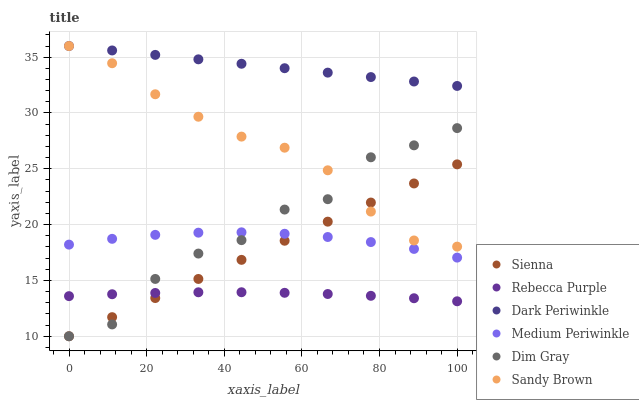Does Rebecca Purple have the minimum area under the curve?
Answer yes or no. Yes. Does Dark Periwinkle have the maximum area under the curve?
Answer yes or no. Yes. Does Medium Periwinkle have the minimum area under the curve?
Answer yes or no. No. Does Medium Periwinkle have the maximum area under the curve?
Answer yes or no. No. Is Dark Periwinkle the smoothest?
Answer yes or no. Yes. Is Dim Gray the roughest?
Answer yes or no. Yes. Is Medium Periwinkle the smoothest?
Answer yes or no. No. Is Medium Periwinkle the roughest?
Answer yes or no. No. Does Dim Gray have the lowest value?
Answer yes or no. Yes. Does Medium Periwinkle have the lowest value?
Answer yes or no. No. Does Dark Periwinkle have the highest value?
Answer yes or no. Yes. Does Medium Periwinkle have the highest value?
Answer yes or no. No. Is Medium Periwinkle less than Dark Periwinkle?
Answer yes or no. Yes. Is Sandy Brown greater than Medium Periwinkle?
Answer yes or no. Yes. Does Dim Gray intersect Sienna?
Answer yes or no. Yes. Is Dim Gray less than Sienna?
Answer yes or no. No. Is Dim Gray greater than Sienna?
Answer yes or no. No. Does Medium Periwinkle intersect Dark Periwinkle?
Answer yes or no. No. 